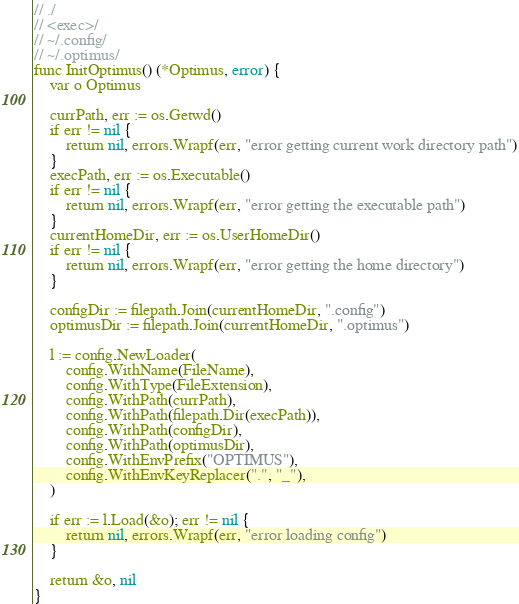Convert code to text. <code><loc_0><loc_0><loc_500><loc_500><_Go_>// ./
// <exec>/
// ~/.config/
// ~/.optimus/
func InitOptimus() (*Optimus, error) {
	var o Optimus

	currPath, err := os.Getwd()
	if err != nil {
		return nil, errors.Wrapf(err, "error getting current work directory path")
	}
	execPath, err := os.Executable()
	if err != nil {
		return nil, errors.Wrapf(err, "error getting the executable path")
	}
	currentHomeDir, err := os.UserHomeDir()
	if err != nil {
		return nil, errors.Wrapf(err, "error getting the home directory")
	}

	configDir := filepath.Join(currentHomeDir, ".config")
	optimusDir := filepath.Join(currentHomeDir, ".optimus")

	l := config.NewLoader(
		config.WithName(FileName),
		config.WithType(FileExtension),
		config.WithPath(currPath),
		config.WithPath(filepath.Dir(execPath)),
		config.WithPath(configDir),
		config.WithPath(optimusDir),
		config.WithEnvPrefix("OPTIMUS"),
		config.WithEnvKeyReplacer(".", "_"),
	)

	if err := l.Load(&o); err != nil {
		return nil, errors.Wrapf(err, "error loading config")
	}

	return &o, nil
}
</code> 